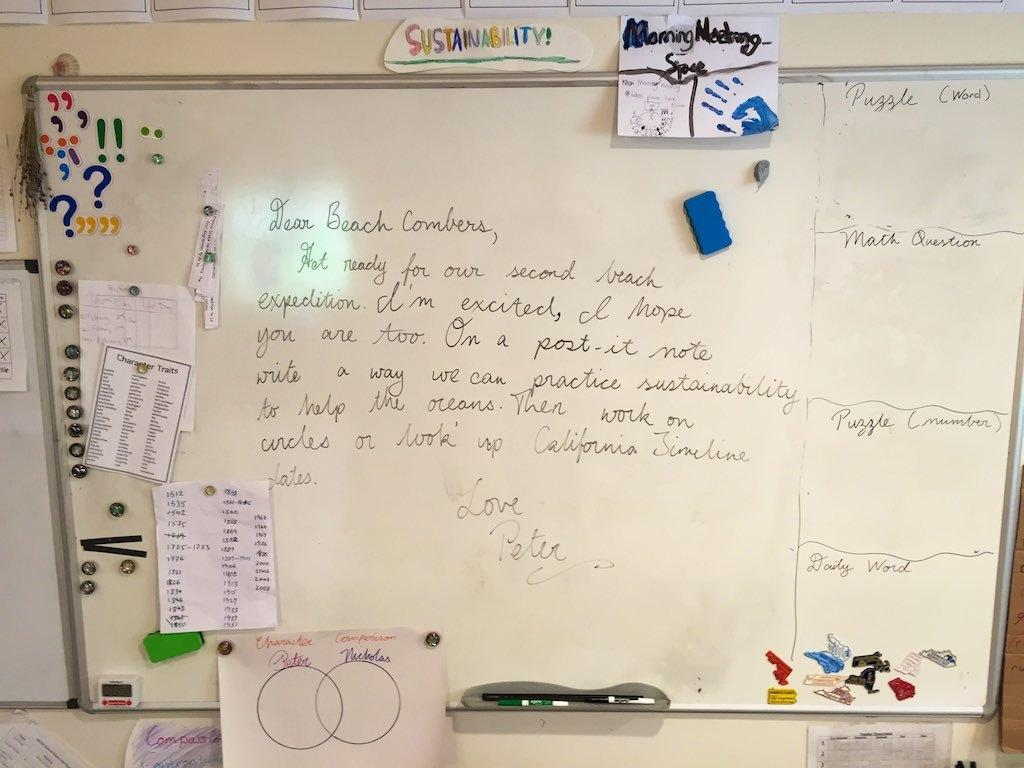<image>
Summarize the visual content of the image. On a white, dry erase board, under the word sustainability, is an assignment geared towards sustainability for the ocean. 